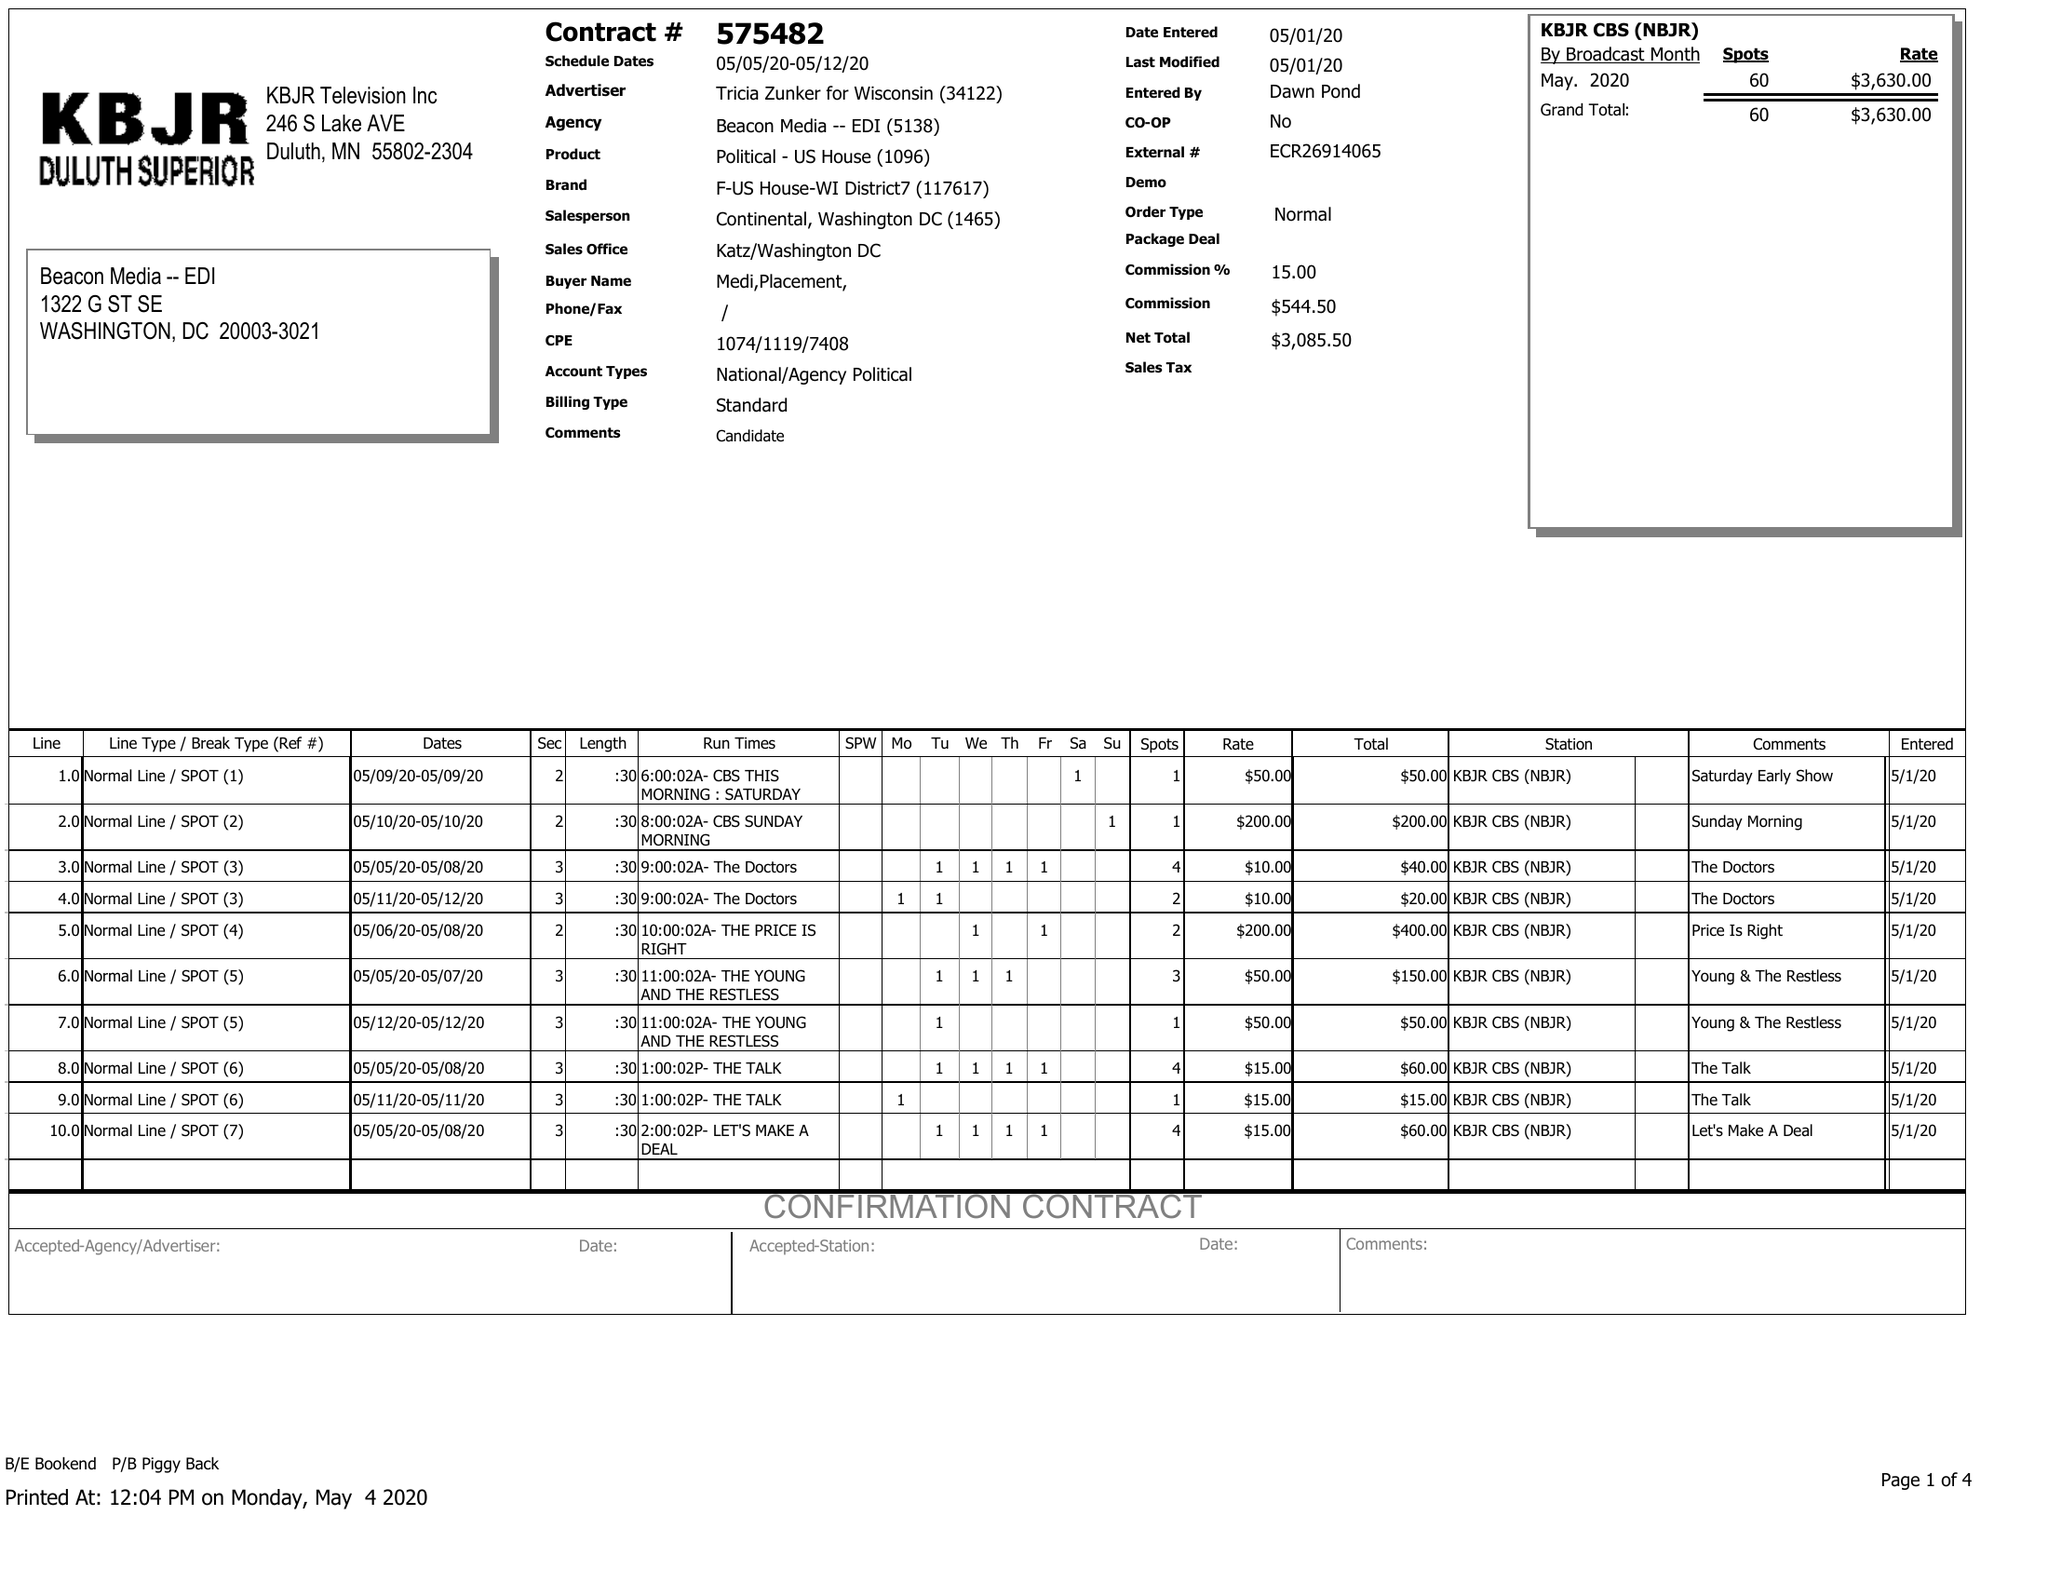What is the value for the flight_from?
Answer the question using a single word or phrase. 05/05/20 